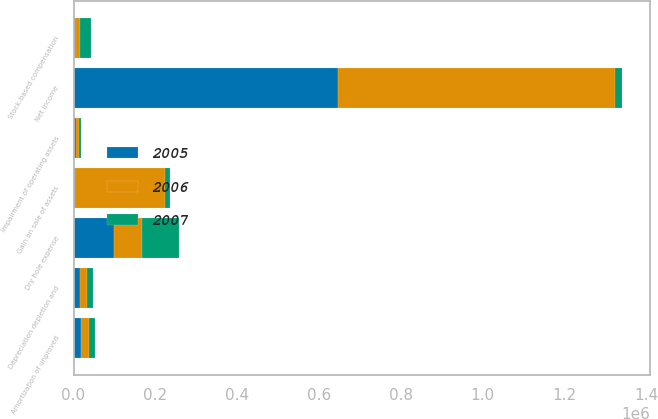Convert chart to OTSL. <chart><loc_0><loc_0><loc_500><loc_500><stacked_bar_chart><ecel><fcel>Net income<fcel>Depreciation depletion and<fcel>Dry hole expense<fcel>Impairment of operating assets<fcel>Amortization of unproved<fcel>Stock-based compensation<fcel>Gain on sale of assets<nl><fcel>2007<fcel>17855<fcel>14277<fcel>90210<fcel>3661<fcel>16013<fcel>26825<fcel>11854<nl><fcel>2006<fcel>678428<fcel>16319<fcel>70325<fcel>8525<fcel>18923<fcel>11816<fcel>219577<nl><fcel>2005<fcel>645720<fcel>16476<fcel>98015<fcel>5368<fcel>17855<fcel>3467<fcel>4201<nl></chart> 